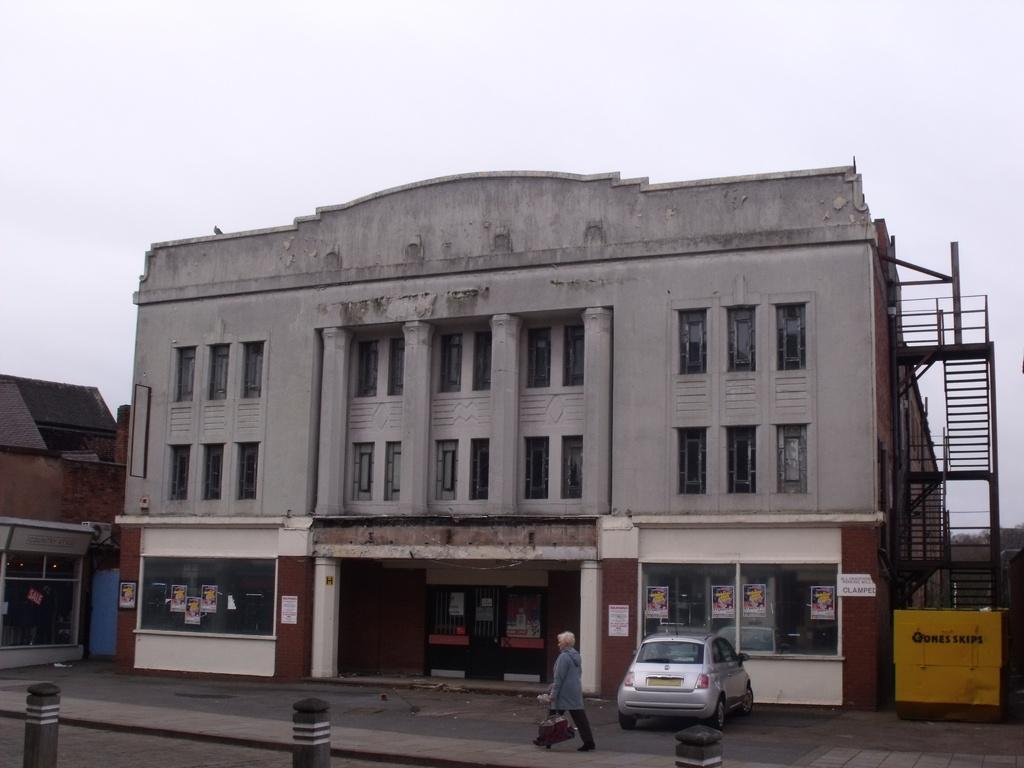What type of structures are present in the image? There are buildings in the image. Can you describe the human in the image? The human is walking and holding a bag. What else can be seen in the image besides the buildings and the human? There are posters in the image. How would you describe the weather based on the image? The sky is cloudy in the image. Are there any architectural features visible in the image? Yes, there are stairs on the side of a building in the image. How many goats are visible on the stairs in the image? There are no goats present in the image; only buildings, a human, posters, and stairs are visible. What type of cream is being used by the girls in the image? There are no girls present in the image, and therefore no cream usage can be observed. 